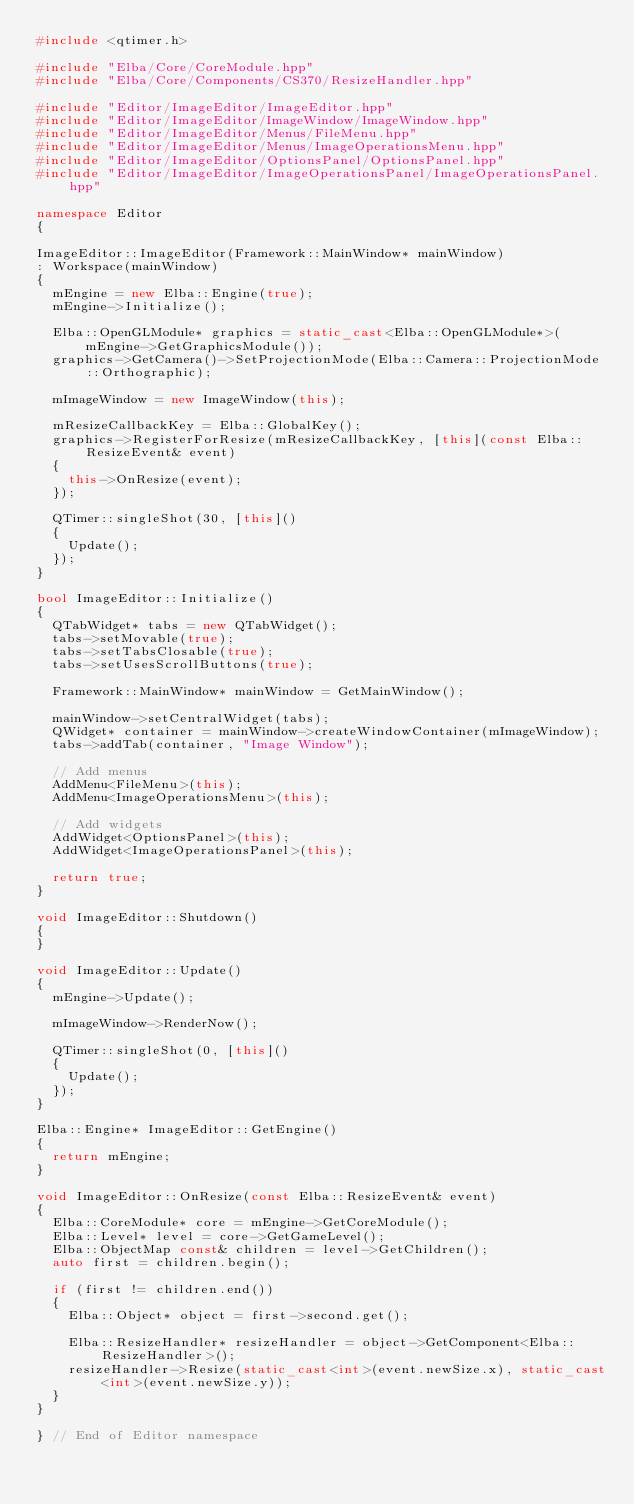<code> <loc_0><loc_0><loc_500><loc_500><_C++_>#include <qtimer.h>

#include "Elba/Core/CoreModule.hpp"
#include "Elba/Core/Components/CS370/ResizeHandler.hpp"

#include "Editor/ImageEditor/ImageEditor.hpp"
#include "Editor/ImageEditor/ImageWindow/ImageWindow.hpp"
#include "Editor/ImageEditor/Menus/FileMenu.hpp"
#include "Editor/ImageEditor/Menus/ImageOperationsMenu.hpp"
#include "Editor/ImageEditor/OptionsPanel/OptionsPanel.hpp"
#include "Editor/ImageEditor/ImageOperationsPanel/ImageOperationsPanel.hpp"

namespace Editor
{

ImageEditor::ImageEditor(Framework::MainWindow* mainWindow)
: Workspace(mainWindow)
{
  mEngine = new Elba::Engine(true);
  mEngine->Initialize();

  Elba::OpenGLModule* graphics = static_cast<Elba::OpenGLModule*>(mEngine->GetGraphicsModule());
  graphics->GetCamera()->SetProjectionMode(Elba::Camera::ProjectionMode::Orthographic);

  mImageWindow = new ImageWindow(this);

  mResizeCallbackKey = Elba::GlobalKey();
  graphics->RegisterForResize(mResizeCallbackKey, [this](const Elba::ResizeEvent& event)
  {
    this->OnResize(event);
  });

  QTimer::singleShot(30, [this]()
  {
    Update();
  });
}

bool ImageEditor::Initialize()
{
  QTabWidget* tabs = new QTabWidget();
  tabs->setMovable(true);
  tabs->setTabsClosable(true);
  tabs->setUsesScrollButtons(true);

  Framework::MainWindow* mainWindow = GetMainWindow();

  mainWindow->setCentralWidget(tabs);
  QWidget* container = mainWindow->createWindowContainer(mImageWindow);
  tabs->addTab(container, "Image Window");

  // Add menus
  AddMenu<FileMenu>(this);
  AddMenu<ImageOperationsMenu>(this);

  // Add widgets
  AddWidget<OptionsPanel>(this);
  AddWidget<ImageOperationsPanel>(this);

  return true;
}

void ImageEditor::Shutdown()
{
}

void ImageEditor::Update()
{
  mEngine->Update();

  mImageWindow->RenderNow();

  QTimer::singleShot(0, [this]()
  {
    Update();
  });
}

Elba::Engine* ImageEditor::GetEngine()
{
  return mEngine;
}

void ImageEditor::OnResize(const Elba::ResizeEvent& event)
{
  Elba::CoreModule* core = mEngine->GetCoreModule();
  Elba::Level* level = core->GetGameLevel();
  Elba::ObjectMap const& children = level->GetChildren();
  auto first = children.begin();

  if (first != children.end())
  {
    Elba::Object* object = first->second.get();
  
    Elba::ResizeHandler* resizeHandler = object->GetComponent<Elba::ResizeHandler>();
    resizeHandler->Resize(static_cast<int>(event.newSize.x), static_cast<int>(event.newSize.y));
  }
}

} // End of Editor namespace
</code> 